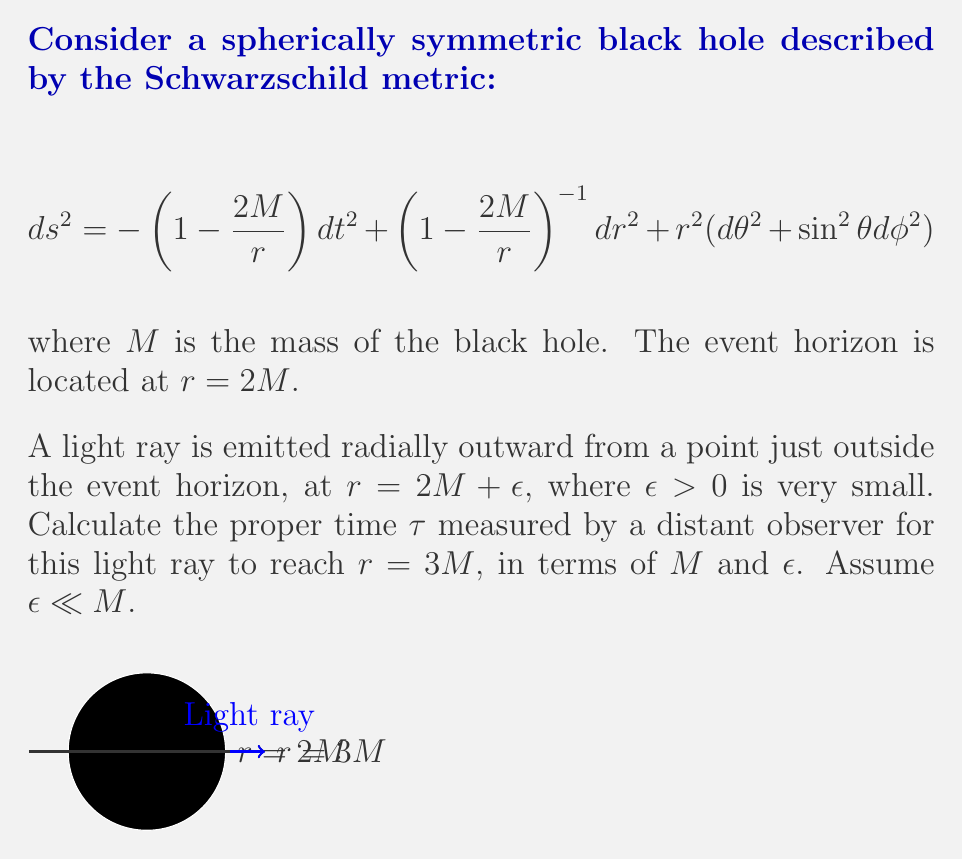Provide a solution to this math problem. Let's approach this step-by-step:

1) For a light ray, we have $ds^2 = 0$. Since the motion is radial, $d\theta = d\phi = 0$. Therefore:

   $$ 0 = -\left(1-\frac{2M}{r}\right)dt^2 + \left(1-\frac{2M}{r}\right)^{-1}dr^2 $$

2) Rearranging this equation:

   $$ dt = \pm \left(1-\frac{2M}{r}\right)^{-1} dr $$

   We take the positive sign as the light is moving outward.

3) To find the coordinate time $t$, we integrate:

   $$ t = \int_{2M+\epsilon}^{3M} \left(1-\frac{2M}{r}\right)^{-1} dr $$

4) This integral can be solved by substitution. Let $u = r/2M$:

   $$ t = 2M \int_{1+\epsilon/(2M)}^{3/2} \frac{du}{u-1} $$

5) The result of this integration is:

   $$ t = 2M \left[\ln(u-1)\right]_{1+\epsilon/(2M)}^{3/2} = 2M \left[\ln\left(\frac{1}{2}\right) - \ln\left(\frac{\epsilon}{2M}\right)\right] $$

6) Simplifying:

   $$ t = 2M \left[\ln\left(\frac{M}{\epsilon}\right) - \ln\left(\frac{1}{2}\right)\right] = 2M \ln\left(\frac{2M}{\epsilon}\right) $$

7) Now, to convert this to proper time $\tau$ for a distant observer, we use the time dilation factor from the Schwarzschild metric. At large distances, $\tau \approx t$, so:

   $$ \tau \approx 2M \ln\left(\frac{2M}{\epsilon}\right) $$

This is our final result, expressed in terms of $M$ and $\epsilon$.
Answer: $\tau \approx 2M \ln\left(\frac{2M}{\epsilon}\right)$ 